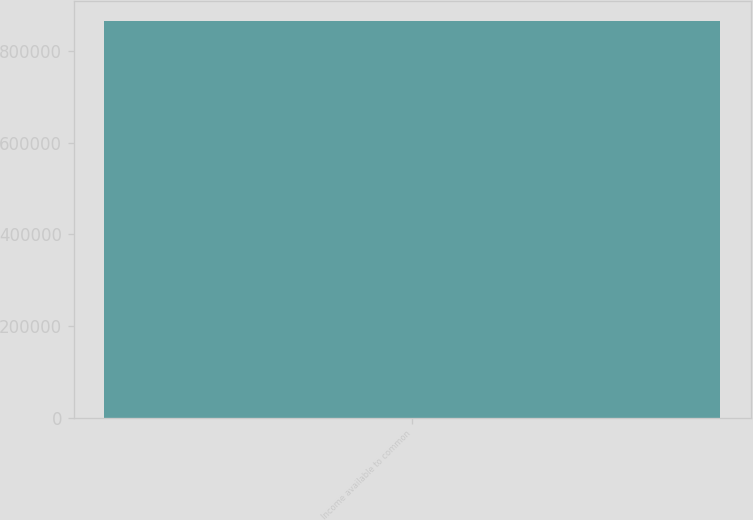Convert chart to OTSL. <chart><loc_0><loc_0><loc_500><loc_500><bar_chart><fcel>Income available to common<nl><fcel>866978<nl></chart> 